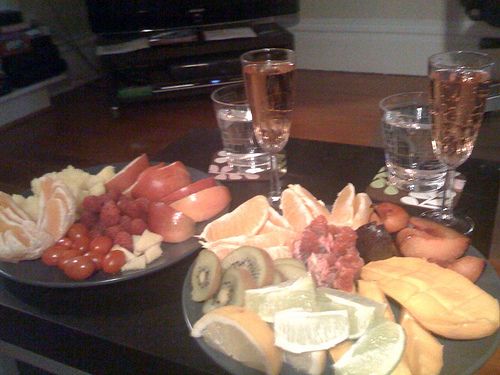How many plates are there? Upon examining the image, there appears to be one large plate that holds an assortment of fruit including orange slices, kiwi, and grapes, along with another smaller plate filled with tomatoes and perhaps berries. If the smaller items such as the fruit portions not on the plate are being counted as individual plates, which is less likely, then there might be more. 